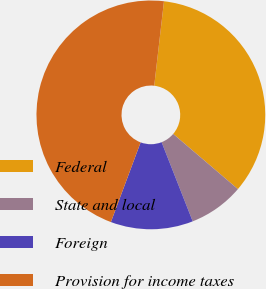<chart> <loc_0><loc_0><loc_500><loc_500><pie_chart><fcel>Federal<fcel>State and local<fcel>Foreign<fcel>Provision for income taxes<nl><fcel>34.41%<fcel>7.8%<fcel>11.64%<fcel>46.15%<nl></chart> 